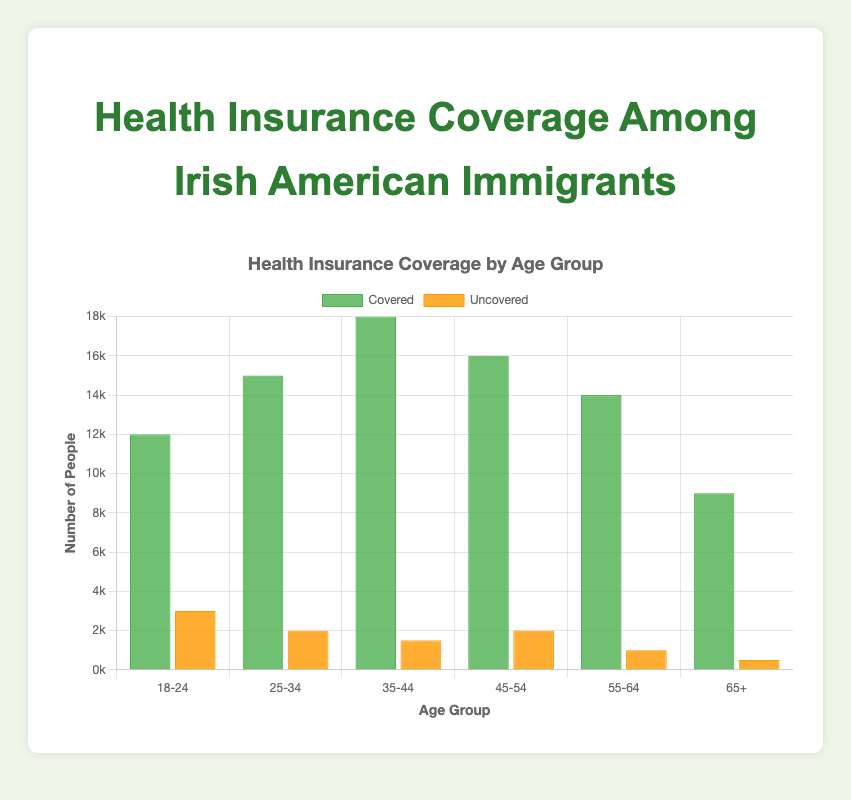What age group has the highest number of people covered by health insurance? The bar representing the 35-44 age group for covered people is the tallest, indicating the highest number of people covered by health insurance in this age group.
Answer: 35-44 What is the total number of people uncovered across all age groups? Add the number of uncovered people in each age group: 3000 (18-24) + 2000 (25-34) + 1500 (35-44) + 2000 (45-54) + 1000 (55-64) + 500 (65+), resulting in 10000.
Answer: 10000 Which age group has the lowest number of uncovered people? The bar representing the 65+ age group for uncovered people is the shortest, indicating the lowest number of uncovered people.
Answer: 65+ Compare the 18-24 and 25-34 age groups in terms of the number of uncovered people. Which one has more? The bar for uncovered people in the 18-24 age group is taller (3000) than that of 25-34 (2000), showing that 18-24 has more uncovered people.
Answer: 18-24 What is the difference in the number of covered people between the 35-44 and 65+ age groups? Subtract the number of covered people in the 65+ age group (9000) from that in the 35-44 age group (18000), which gives a difference of 9000.
Answer: 9000 Calculate the total number of people (covered and uncovered) in the 25-34 age group. Sum the covered (15000) and uncovered (2000) people in the 25-34 age group, resulting in a total of 17000.
Answer: 17000 What is the total number of people covered by health insurance across all age groups? Add the number of covered people in each age group: 12000 (18-24) + 15000 (25-34) + 18000 (35-44) + 16000 (45-54) + 14000 (55-64) + 9000 (65+), resulting in 84000.
Answer: 84000 How many more people are covered compared to uncovered in the 45-54 age group? Subtract the number of uncovered people in the 45-54 age group (2000) from the number of covered people (16000), resulting in 14000 more people covered.
Answer: 14000 